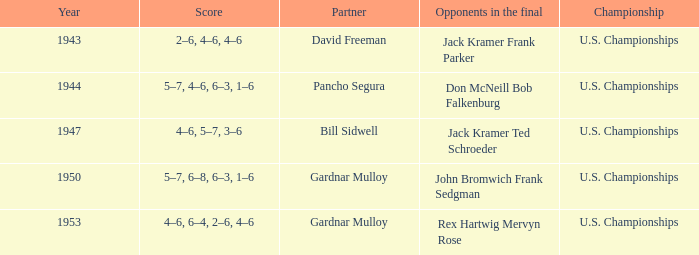Which Partner has Opponents in the final of john bromwich frank sedgman? Gardnar Mulloy. 